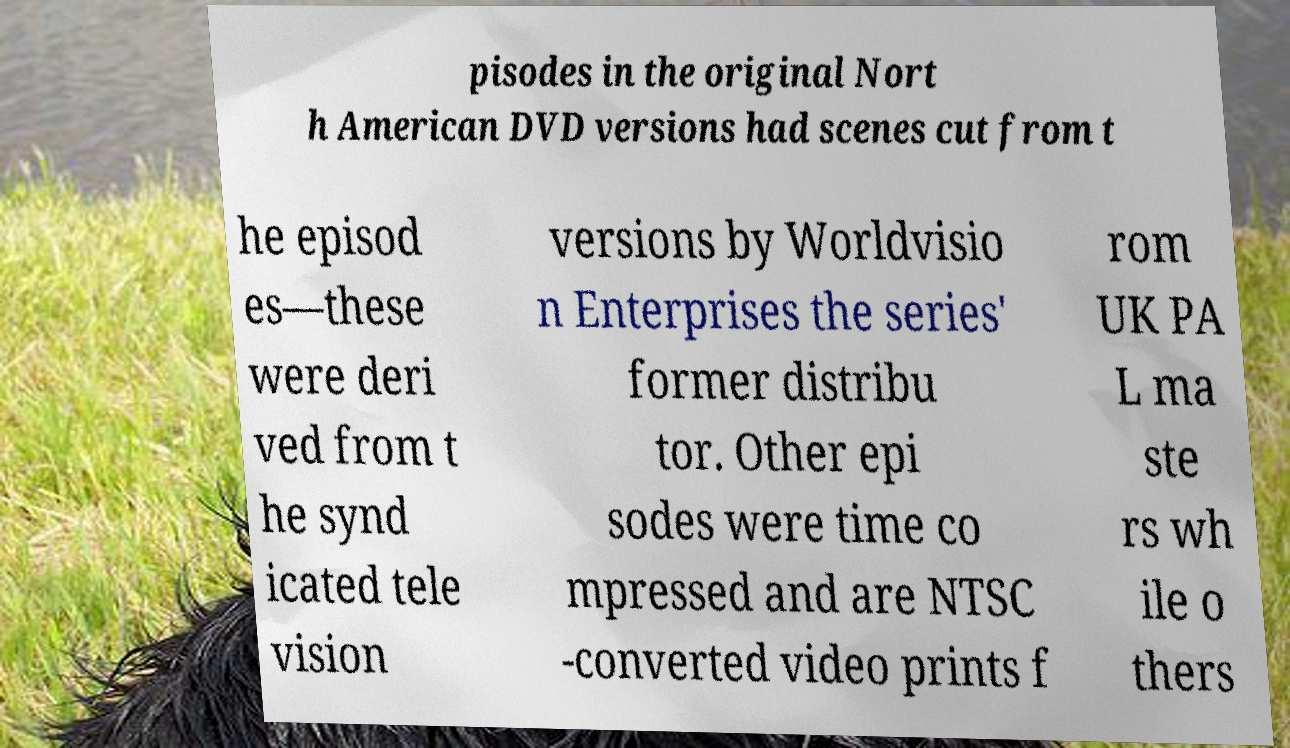Please identify and transcribe the text found in this image. pisodes in the original Nort h American DVD versions had scenes cut from t he episod es—these were deri ved from t he synd icated tele vision versions by Worldvisio n Enterprises the series' former distribu tor. Other epi sodes were time co mpressed and are NTSC -converted video prints f rom UK PA L ma ste rs wh ile o thers 